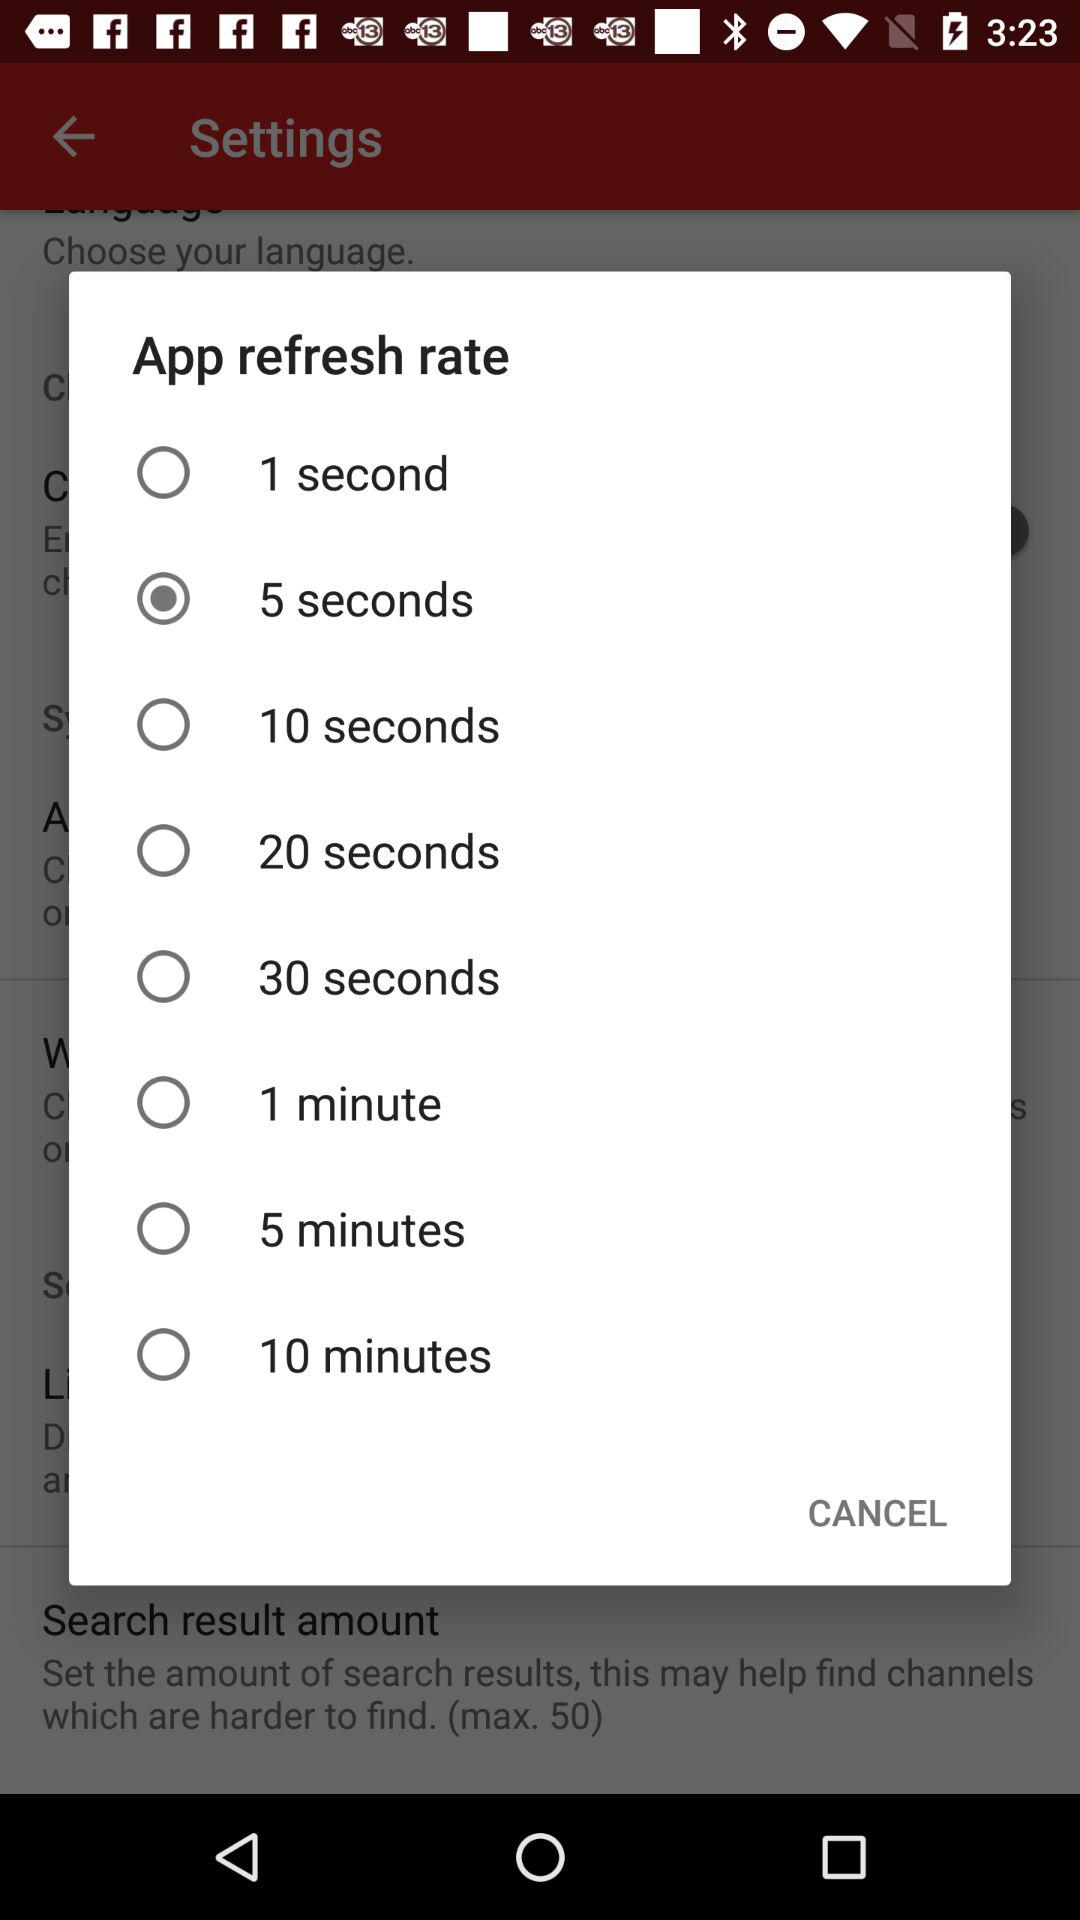How many seconds is the longest refresh rate?
Answer the question using a single word or phrase. 10 minutes 